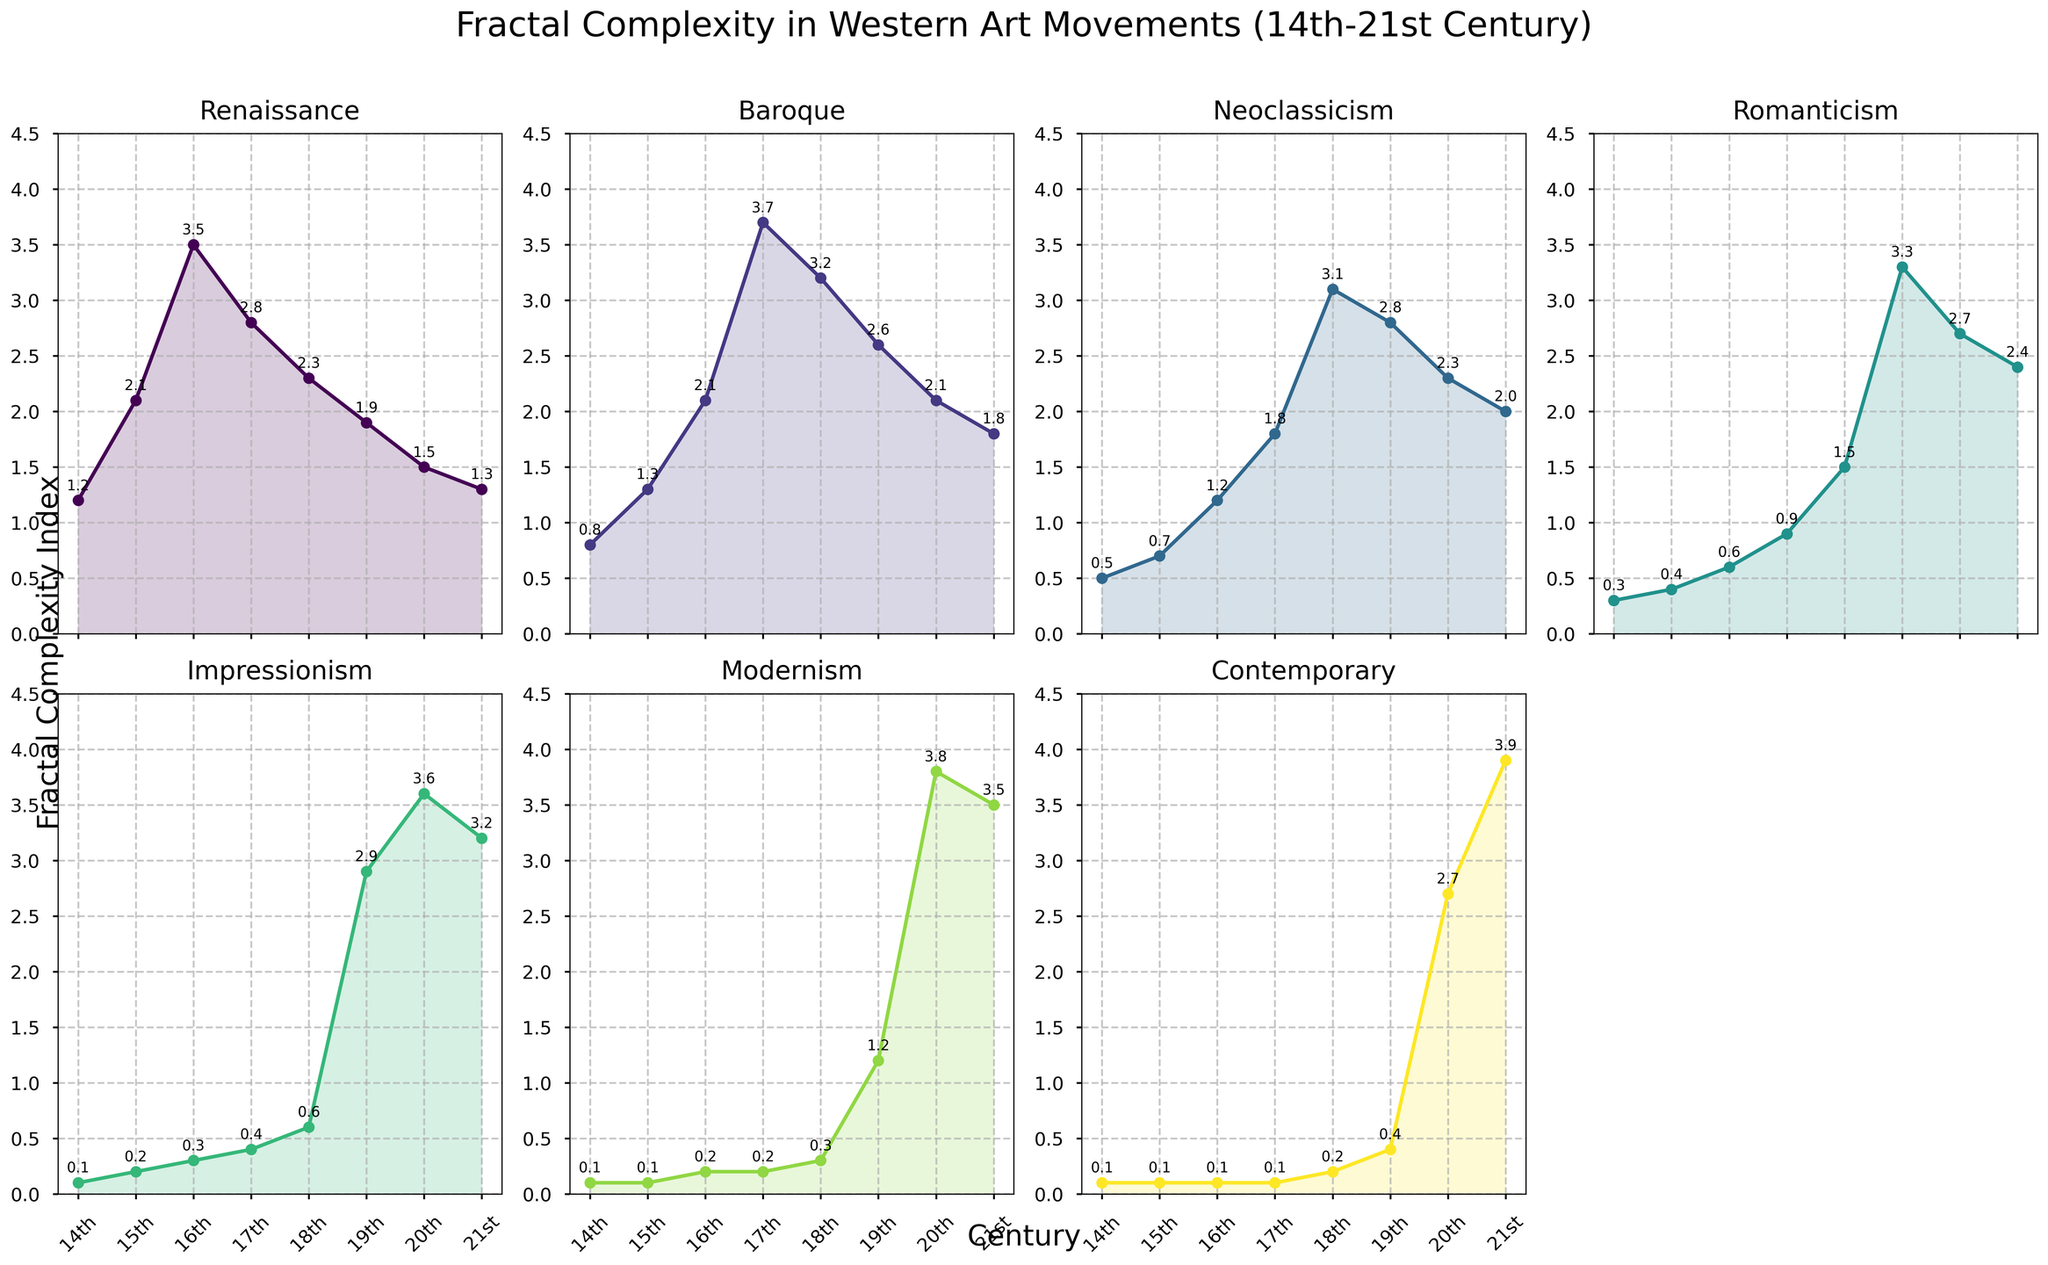What is the title of the figure? The title appears at the top center of the figure, reading "Fractal Complexity in Western Art Movements (14th-21st Century)".
Answer: Fractal Complexity in Western Art Movements (14th-21st Century) Which century shows the highest fractal complexity in Baroque? By observing the Baroque plot, the highest point appears around the 17th century.
Answer: The 17th century How many art movements are being compared in the subplots? There are seven subplots, each labeled with a different art movement.
Answer: Seven Compare the fractal complexity in the 19th century between Impressionism and Neoclassicism. Which is higher? The 19th-century values for Impressionism and Neoclassicism in their respective subplots are 2.9 and 2.8. Impressionism is slightly higher.
Answer: Impressionism What trend do you observe in Modernism from the 19th to the 21st century? The Modernism plot shows a steep increase in fractal complexity from 1.2 in the 19th century to 3.8 in the 20th century, then a slight decrease to 3.5 in the 21st century.
Answer: Increasing trend with a slight decrease What is the difference in fractal complexity between the 15th and 14th centuries in Renaissance? The values for Renaissance in the 15th and 14th centuries are 2.1 and 1.2, respectively. Subtracting these gives 2.1 - 1.2.
Answer: 0.9 Which century has the lowest fractal complexity in Romanticism? In the Romanticism subplot, the smallest value is observed in the 14th century, which is 0.3.
Answer: The 14th century In which century does Contemporary art reach its peak fractal complexity? The Contemporary plot shows an upward trend, peaking in the 21st century at 3.9.
Answer: The 21st century What is the average fractal complexity for Neoclassicism from the 18th to 21st centuries? The values are 3.1 (18th), 2.8 (19th), 2.3 (20th), and 2.0 (21st). Averaging these: (3.1 + 2.8 + 2.3 + 2.0) / 4.
Answer: 2.55 